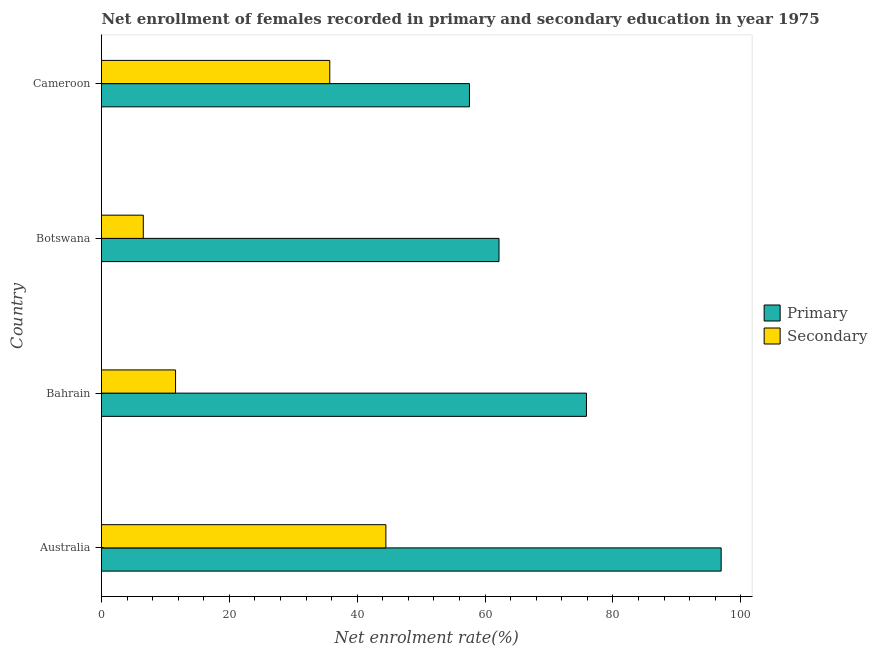How many different coloured bars are there?
Your answer should be compact. 2. Are the number of bars per tick equal to the number of legend labels?
Offer a very short reply. Yes. How many bars are there on the 1st tick from the top?
Offer a terse response. 2. In how many cases, is the number of bars for a given country not equal to the number of legend labels?
Your answer should be very brief. 0. What is the enrollment rate in primary education in Botswana?
Provide a short and direct response. 62.19. Across all countries, what is the maximum enrollment rate in primary education?
Provide a short and direct response. 96.94. Across all countries, what is the minimum enrollment rate in secondary education?
Your answer should be very brief. 6.54. In which country was the enrollment rate in primary education minimum?
Offer a very short reply. Cameroon. What is the total enrollment rate in primary education in the graph?
Offer a very short reply. 292.56. What is the difference between the enrollment rate in primary education in Bahrain and that in Cameroon?
Your answer should be compact. 18.3. What is the difference between the enrollment rate in primary education in Botswana and the enrollment rate in secondary education in Cameroon?
Ensure brevity in your answer.  26.47. What is the average enrollment rate in primary education per country?
Make the answer very short. 73.14. What is the difference between the enrollment rate in primary education and enrollment rate in secondary education in Botswana?
Give a very brief answer. 55.65. What is the ratio of the enrollment rate in primary education in Australia to that in Botswana?
Make the answer very short. 1.56. What is the difference between the highest and the second highest enrollment rate in primary education?
Give a very brief answer. 21.07. What is the difference between the highest and the lowest enrollment rate in secondary education?
Offer a terse response. 37.95. What does the 1st bar from the top in Cameroon represents?
Your answer should be compact. Secondary. What does the 1st bar from the bottom in Cameroon represents?
Offer a terse response. Primary. Are all the bars in the graph horizontal?
Offer a very short reply. Yes. What is the difference between two consecutive major ticks on the X-axis?
Give a very brief answer. 20. Are the values on the major ticks of X-axis written in scientific E-notation?
Make the answer very short. No. Does the graph contain any zero values?
Your answer should be compact. No. Does the graph contain grids?
Your response must be concise. No. Where does the legend appear in the graph?
Make the answer very short. Center right. How many legend labels are there?
Your response must be concise. 2. How are the legend labels stacked?
Ensure brevity in your answer.  Vertical. What is the title of the graph?
Give a very brief answer. Net enrollment of females recorded in primary and secondary education in year 1975. What is the label or title of the X-axis?
Your response must be concise. Net enrolment rate(%). What is the label or title of the Y-axis?
Your answer should be compact. Country. What is the Net enrolment rate(%) of Primary in Australia?
Offer a very short reply. 96.94. What is the Net enrolment rate(%) in Secondary in Australia?
Make the answer very short. 44.49. What is the Net enrolment rate(%) in Primary in Bahrain?
Keep it short and to the point. 75.87. What is the Net enrolment rate(%) in Secondary in Bahrain?
Provide a succinct answer. 11.59. What is the Net enrolment rate(%) of Primary in Botswana?
Keep it short and to the point. 62.19. What is the Net enrolment rate(%) in Secondary in Botswana?
Offer a very short reply. 6.54. What is the Net enrolment rate(%) in Primary in Cameroon?
Your answer should be very brief. 57.57. What is the Net enrolment rate(%) in Secondary in Cameroon?
Offer a terse response. 35.71. Across all countries, what is the maximum Net enrolment rate(%) of Primary?
Offer a very short reply. 96.94. Across all countries, what is the maximum Net enrolment rate(%) in Secondary?
Ensure brevity in your answer.  44.49. Across all countries, what is the minimum Net enrolment rate(%) in Primary?
Your response must be concise. 57.57. Across all countries, what is the minimum Net enrolment rate(%) in Secondary?
Your response must be concise. 6.54. What is the total Net enrolment rate(%) of Primary in the graph?
Your response must be concise. 292.56. What is the total Net enrolment rate(%) in Secondary in the graph?
Make the answer very short. 98.32. What is the difference between the Net enrolment rate(%) in Primary in Australia and that in Bahrain?
Offer a terse response. 21.07. What is the difference between the Net enrolment rate(%) in Secondary in Australia and that in Bahrain?
Offer a terse response. 32.9. What is the difference between the Net enrolment rate(%) of Primary in Australia and that in Botswana?
Offer a very short reply. 34.75. What is the difference between the Net enrolment rate(%) of Secondary in Australia and that in Botswana?
Your answer should be very brief. 37.95. What is the difference between the Net enrolment rate(%) of Primary in Australia and that in Cameroon?
Make the answer very short. 39.37. What is the difference between the Net enrolment rate(%) of Secondary in Australia and that in Cameroon?
Provide a succinct answer. 8.77. What is the difference between the Net enrolment rate(%) of Primary in Bahrain and that in Botswana?
Give a very brief answer. 13.68. What is the difference between the Net enrolment rate(%) of Secondary in Bahrain and that in Botswana?
Your answer should be compact. 5.05. What is the difference between the Net enrolment rate(%) in Primary in Bahrain and that in Cameroon?
Your answer should be very brief. 18.3. What is the difference between the Net enrolment rate(%) of Secondary in Bahrain and that in Cameroon?
Make the answer very short. -24.13. What is the difference between the Net enrolment rate(%) in Primary in Botswana and that in Cameroon?
Make the answer very short. 4.62. What is the difference between the Net enrolment rate(%) in Secondary in Botswana and that in Cameroon?
Keep it short and to the point. -29.17. What is the difference between the Net enrolment rate(%) of Primary in Australia and the Net enrolment rate(%) of Secondary in Bahrain?
Ensure brevity in your answer.  85.35. What is the difference between the Net enrolment rate(%) of Primary in Australia and the Net enrolment rate(%) of Secondary in Botswana?
Give a very brief answer. 90.4. What is the difference between the Net enrolment rate(%) of Primary in Australia and the Net enrolment rate(%) of Secondary in Cameroon?
Provide a short and direct response. 61.23. What is the difference between the Net enrolment rate(%) in Primary in Bahrain and the Net enrolment rate(%) in Secondary in Botswana?
Give a very brief answer. 69.33. What is the difference between the Net enrolment rate(%) of Primary in Bahrain and the Net enrolment rate(%) of Secondary in Cameroon?
Your answer should be very brief. 40.16. What is the difference between the Net enrolment rate(%) in Primary in Botswana and the Net enrolment rate(%) in Secondary in Cameroon?
Offer a very short reply. 26.47. What is the average Net enrolment rate(%) of Primary per country?
Your answer should be very brief. 73.14. What is the average Net enrolment rate(%) of Secondary per country?
Offer a terse response. 24.58. What is the difference between the Net enrolment rate(%) in Primary and Net enrolment rate(%) in Secondary in Australia?
Your answer should be very brief. 52.45. What is the difference between the Net enrolment rate(%) of Primary and Net enrolment rate(%) of Secondary in Bahrain?
Make the answer very short. 64.28. What is the difference between the Net enrolment rate(%) of Primary and Net enrolment rate(%) of Secondary in Botswana?
Make the answer very short. 55.65. What is the difference between the Net enrolment rate(%) of Primary and Net enrolment rate(%) of Secondary in Cameroon?
Make the answer very short. 21.85. What is the ratio of the Net enrolment rate(%) of Primary in Australia to that in Bahrain?
Make the answer very short. 1.28. What is the ratio of the Net enrolment rate(%) in Secondary in Australia to that in Bahrain?
Give a very brief answer. 3.84. What is the ratio of the Net enrolment rate(%) in Primary in Australia to that in Botswana?
Provide a succinct answer. 1.56. What is the ratio of the Net enrolment rate(%) in Secondary in Australia to that in Botswana?
Give a very brief answer. 6.8. What is the ratio of the Net enrolment rate(%) in Primary in Australia to that in Cameroon?
Make the answer very short. 1.68. What is the ratio of the Net enrolment rate(%) of Secondary in Australia to that in Cameroon?
Your answer should be very brief. 1.25. What is the ratio of the Net enrolment rate(%) in Primary in Bahrain to that in Botswana?
Give a very brief answer. 1.22. What is the ratio of the Net enrolment rate(%) in Secondary in Bahrain to that in Botswana?
Provide a short and direct response. 1.77. What is the ratio of the Net enrolment rate(%) of Primary in Bahrain to that in Cameroon?
Make the answer very short. 1.32. What is the ratio of the Net enrolment rate(%) of Secondary in Bahrain to that in Cameroon?
Make the answer very short. 0.32. What is the ratio of the Net enrolment rate(%) of Primary in Botswana to that in Cameroon?
Provide a short and direct response. 1.08. What is the ratio of the Net enrolment rate(%) of Secondary in Botswana to that in Cameroon?
Your answer should be compact. 0.18. What is the difference between the highest and the second highest Net enrolment rate(%) of Primary?
Provide a succinct answer. 21.07. What is the difference between the highest and the second highest Net enrolment rate(%) in Secondary?
Ensure brevity in your answer.  8.77. What is the difference between the highest and the lowest Net enrolment rate(%) of Primary?
Your answer should be compact. 39.37. What is the difference between the highest and the lowest Net enrolment rate(%) of Secondary?
Ensure brevity in your answer.  37.95. 